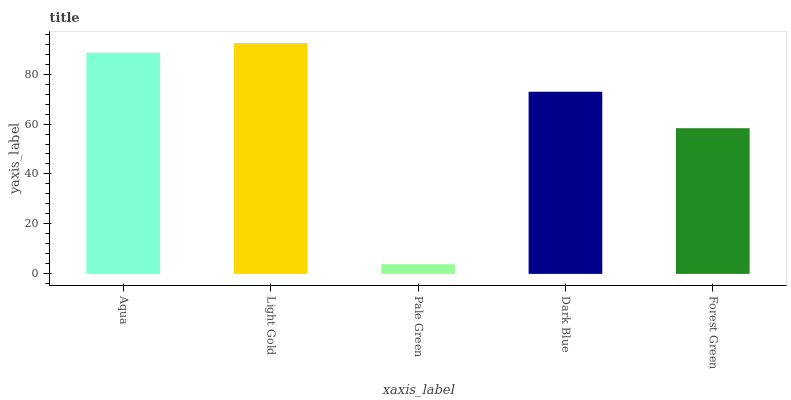Is Pale Green the minimum?
Answer yes or no. Yes. Is Light Gold the maximum?
Answer yes or no. Yes. Is Light Gold the minimum?
Answer yes or no. No. Is Pale Green the maximum?
Answer yes or no. No. Is Light Gold greater than Pale Green?
Answer yes or no. Yes. Is Pale Green less than Light Gold?
Answer yes or no. Yes. Is Pale Green greater than Light Gold?
Answer yes or no. No. Is Light Gold less than Pale Green?
Answer yes or no. No. Is Dark Blue the high median?
Answer yes or no. Yes. Is Dark Blue the low median?
Answer yes or no. Yes. Is Aqua the high median?
Answer yes or no. No. Is Forest Green the low median?
Answer yes or no. No. 